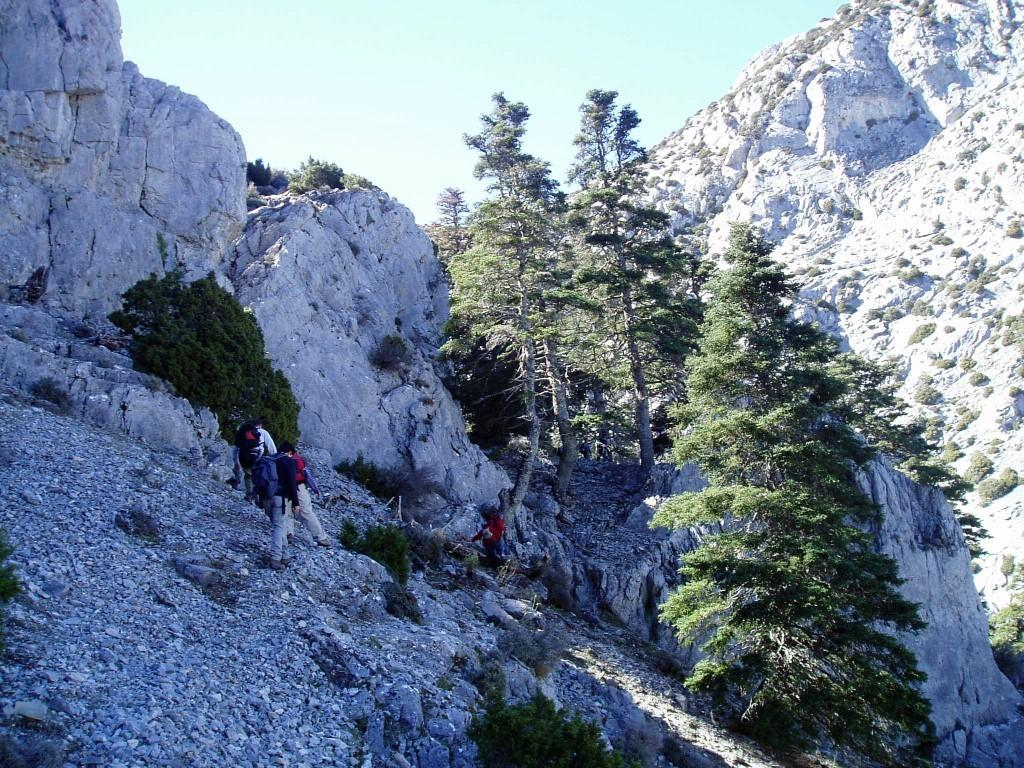What type of natural features can be seen in the image? There are rocks, trees, plants, and a mountain in the image. What objects are present in the image? There are stones and a mountain in the image. Are there any living beings in the image? Yes, there are people in the image. What are some of the people carrying? Some people are wearing backpacks. What is visible at the top of the image? The sky is visible at the top of the image. What type of calculator can be seen in the image? There is no calculator present in the image. Is there a ring visible on any of the people's fingers in the image? There is no ring visible on any of the people's fingers in the image. 